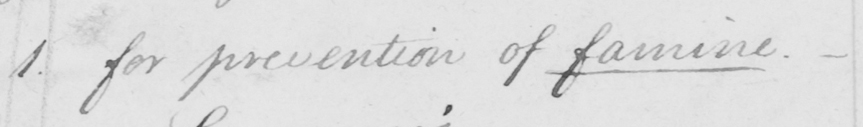Can you tell me what this handwritten text says? 1 . for prevention of famine .  _ 